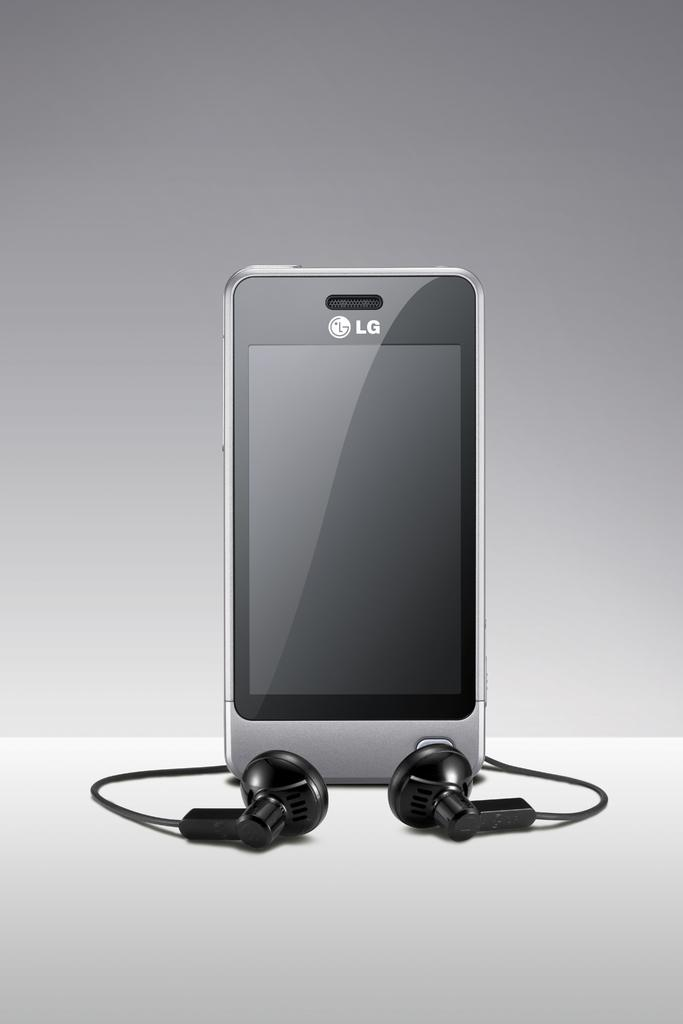Provide a one-sentence caption for the provided image. A silver LG phone sits with a pair of wired earbuds. 